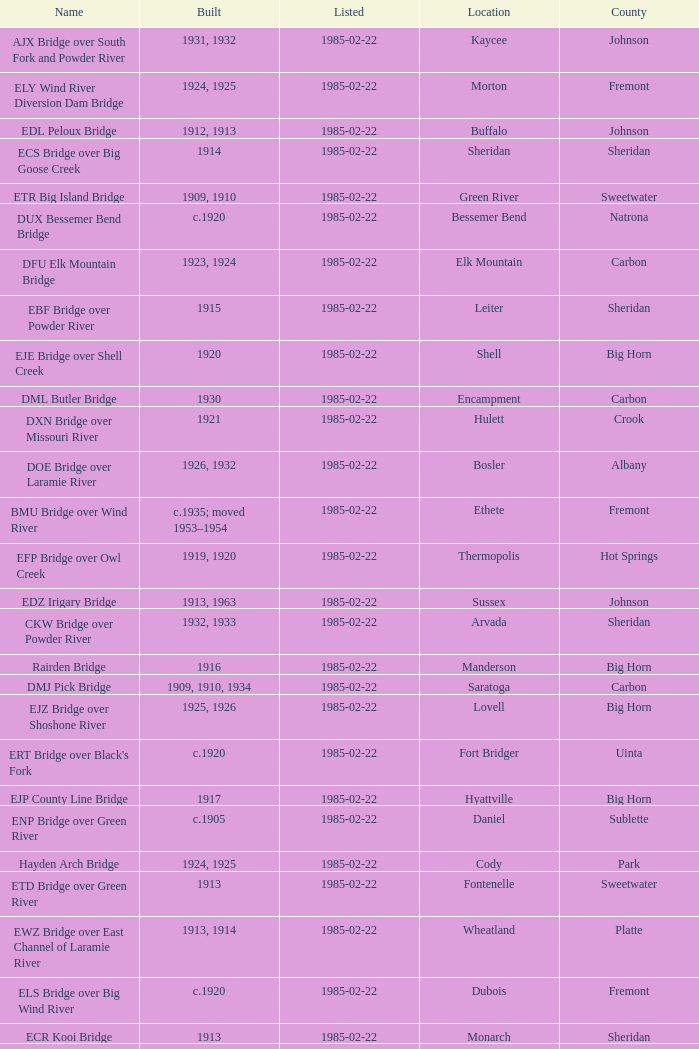In what year was the bridge in Lovell built? 1925, 1926. 